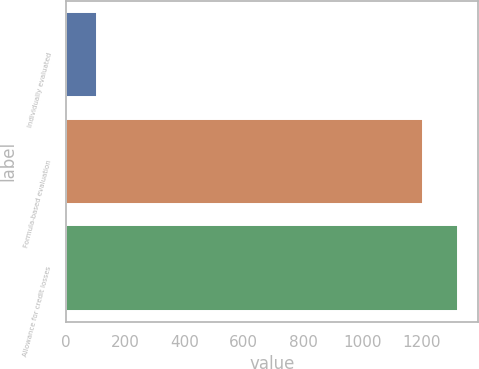Convert chart. <chart><loc_0><loc_0><loc_500><loc_500><bar_chart><fcel>Individually evaluated<fcel>Formula-based evaluation<fcel>Allowance for credit losses<nl><fcel>106<fcel>1202<fcel>1322.2<nl></chart> 